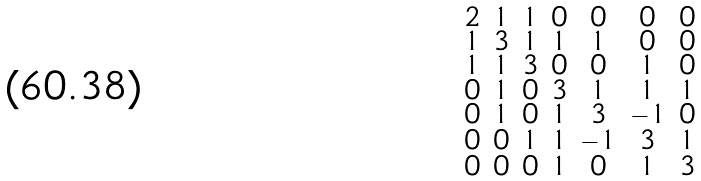<formula> <loc_0><loc_0><loc_500><loc_500>\begin{smallmatrix} 2 & 1 & 1 & 0 & 0 & 0 & 0 \\ 1 & 3 & 1 & 1 & 1 & 0 & 0 \\ 1 & 1 & 3 & 0 & 0 & 1 & 0 \\ 0 & 1 & 0 & 3 & 1 & 1 & 1 \\ 0 & 1 & 0 & 1 & 3 & - 1 & 0 \\ 0 & 0 & 1 & 1 & - 1 & 3 & 1 \\ 0 & 0 & 0 & 1 & 0 & 1 & 3 \end{smallmatrix}</formula> 